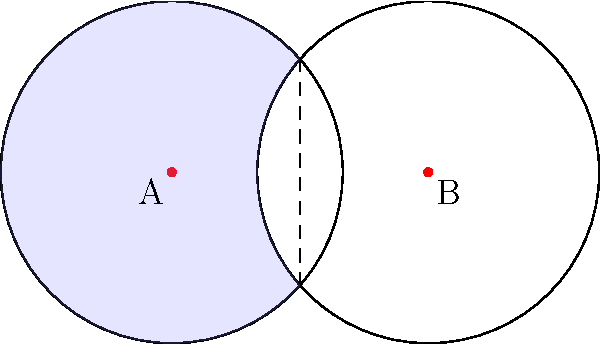In the context of sound wave interference patterns, two overlapping circular sound waves are represented by the circles in the diagram. Both circles have a radius of 1 unit, and their centers are 1.5 units apart. Calculate the area of the overlapping region (shaded in light blue), which represents the interference pattern. Round your answer to three decimal places. To find the area of the overlapping region, we'll follow these steps:

1) First, we need to find the angle $\theta$ at the center of each circle that forms the overlap:

   $\cos(\frac{\theta}{2}) = \frac{0.75}{1} = 0.75$
   $\theta = 2 \arccos(0.75) \approx 1.5708$ radians

2) The area of the overlapping region is twice the area of a circular sector minus the area of an isosceles triangle:

   $A = 2(\text{Area of sector} - \text{Area of triangle})$

3) Area of the sector:
   $A_{sector} = \frac{1}{2}r^2\theta = \frac{1}{2} \cdot 1^2 \cdot 1.5708 = 0.7854$

4) Area of the isosceles triangle:
   $A_{triangle} = \frac{1}{2} \cdot 1.5 \cdot \sqrt{1^2 - 0.75^2} = 0.4841$

5) Therefore, the total overlapping area is:
   $A = 2(0.7854 - 0.4841) = 2(0.3013) = 0.6026$

6) Rounding to three decimal places: 0.603 square units.
Answer: 0.603 square units 